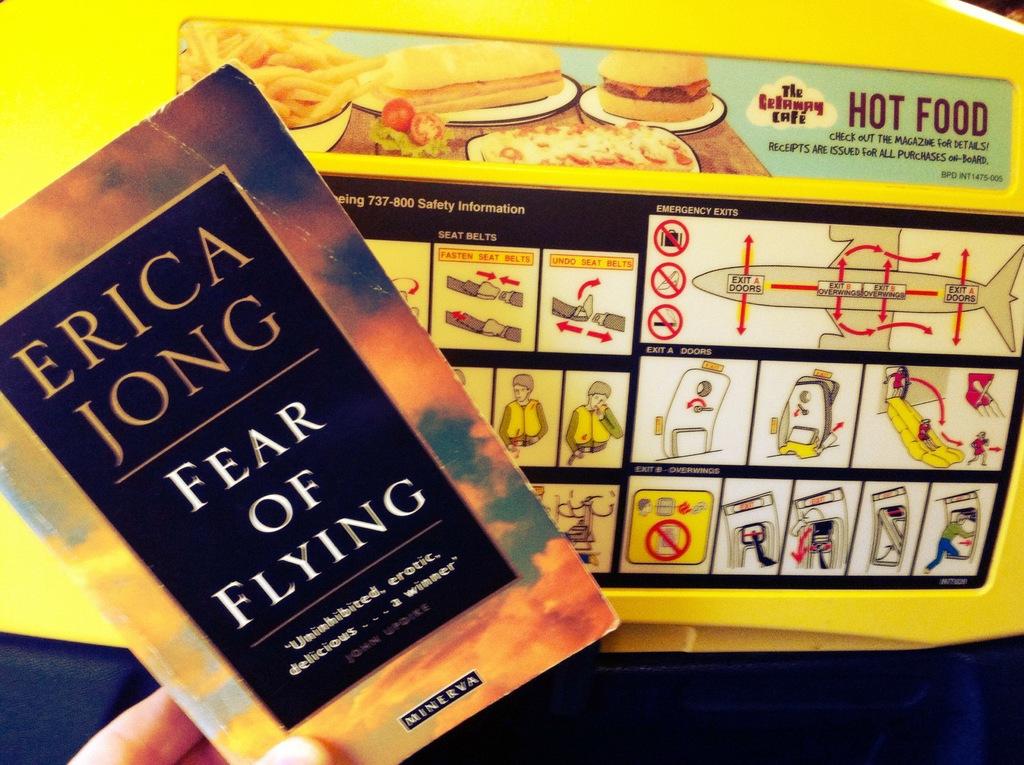What is the book found on the airplane?
Keep it short and to the point. Fear of flying. What kind of food is served on the plane?
Your answer should be compact. Hot food. 